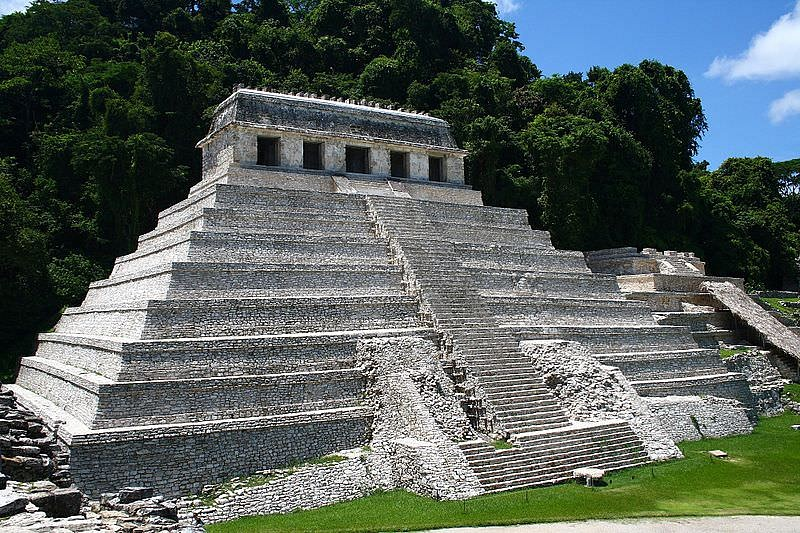Explain the visual content of the image in great detail. The image showcases the Temple of the Inscriptions, a majestic Mayan pyramid located in Palenque, Mexico. Constructed from limestone, the temple is an emblematic example of Mayan architecture with a step-pyramid structure crowned by an elaborate temple top, which houses hieroglyphic inscriptions providing insights into Mayan history and civilization. The steps of the pyramid are broad and steep, hinting at the rigorous ascent required to reach the top where priests or royalty might have performed religious ceremonies or addressed the populace. The preservation of this structure, amidst dense lush greenery that typifies the tropical setting of Chiapas, underscores both the architectural prowess and the deep connection the Mayans had with their natural environment. This site is not just an archaeological asset but also a conduit into understanding the social, religious, and political life of the ancient Mayan culture. 